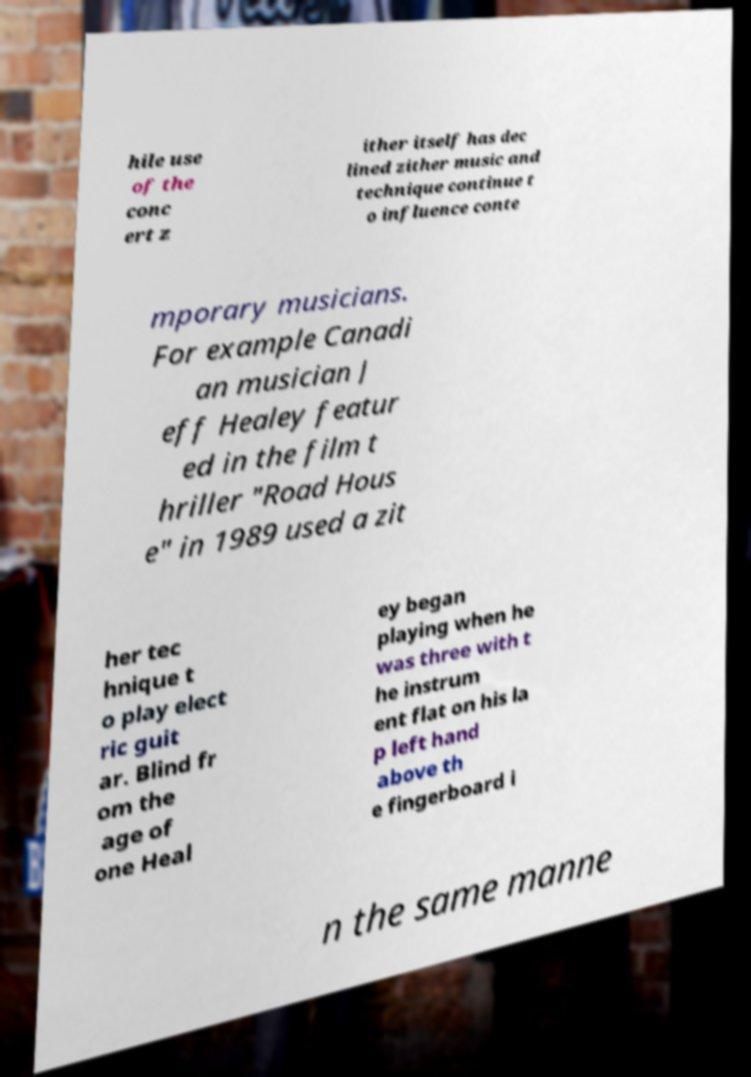Could you extract and type out the text from this image? hile use of the conc ert z ither itself has dec lined zither music and technique continue t o influence conte mporary musicians. For example Canadi an musician J eff Healey featur ed in the film t hriller "Road Hous e" in 1989 used a zit her tec hnique t o play elect ric guit ar. Blind fr om the age of one Heal ey began playing when he was three with t he instrum ent flat on his la p left hand above th e fingerboard i n the same manne 